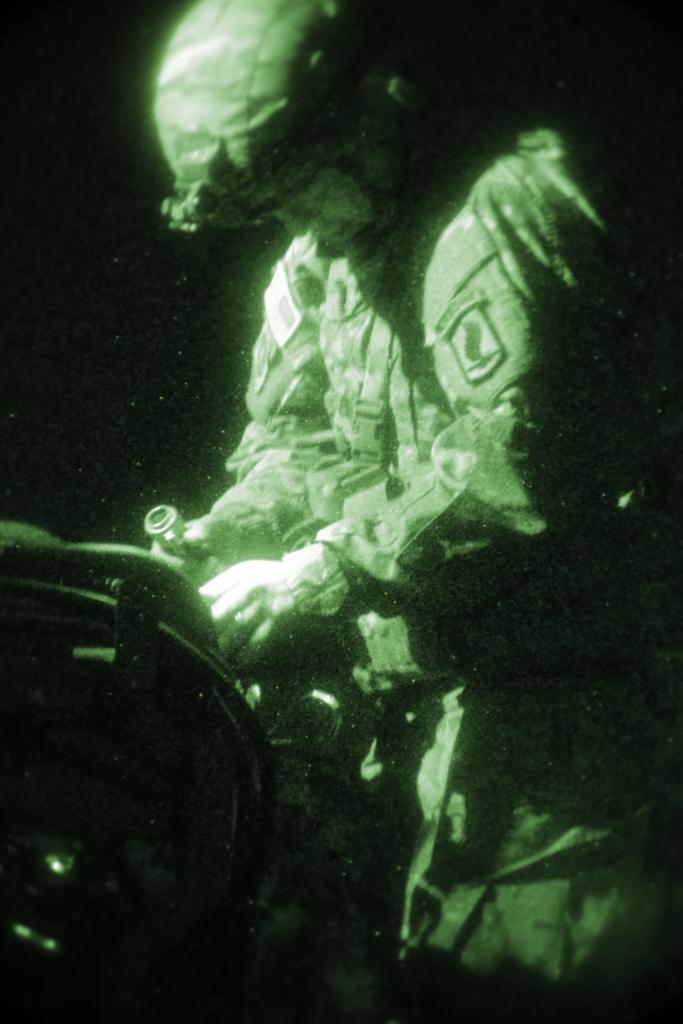What can be seen in the image? There is a person in the image. What is the person doing in the image? The person is holding an object. Can you describe the object on the left side of the image? There is an object on the left side of the image, but its description is not provided in the facts. How would you describe the overall appearance of the image? The background of the image is dark. What type of paste is being used by the person in the image? There is no paste present in the image, and the person's actions do not involve using any paste. 